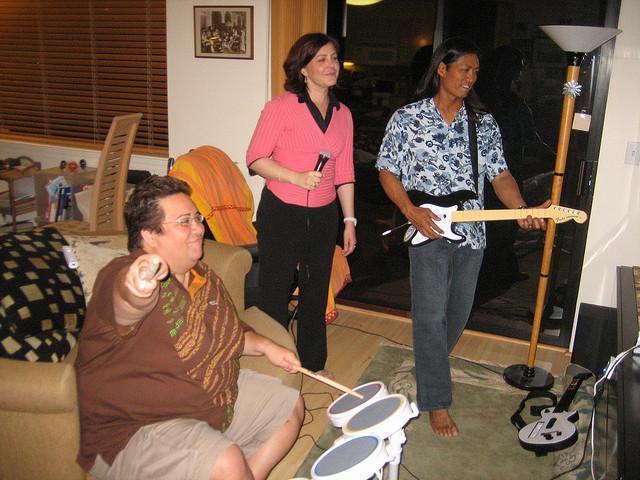What activity is being shared by the people?
Pick the correct solution from the four options below to address the question.
Options: Cooking, video gaming, karaoke, live audition. Video gaming. 